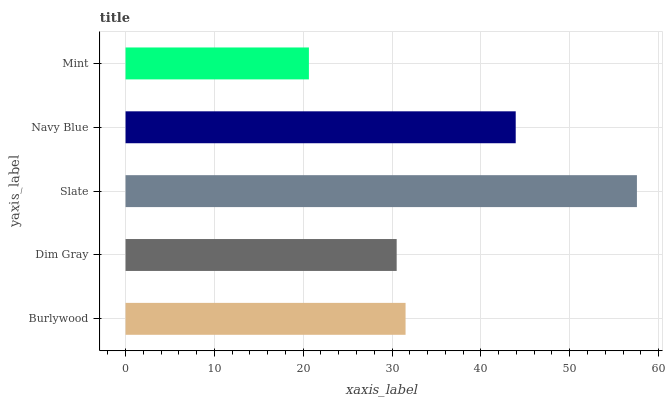Is Mint the minimum?
Answer yes or no. Yes. Is Slate the maximum?
Answer yes or no. Yes. Is Dim Gray the minimum?
Answer yes or no. No. Is Dim Gray the maximum?
Answer yes or no. No. Is Burlywood greater than Dim Gray?
Answer yes or no. Yes. Is Dim Gray less than Burlywood?
Answer yes or no. Yes. Is Dim Gray greater than Burlywood?
Answer yes or no. No. Is Burlywood less than Dim Gray?
Answer yes or no. No. Is Burlywood the high median?
Answer yes or no. Yes. Is Burlywood the low median?
Answer yes or no. Yes. Is Slate the high median?
Answer yes or no. No. Is Mint the low median?
Answer yes or no. No. 